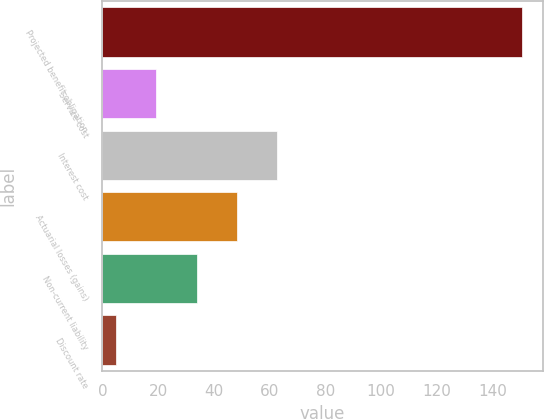Convert chart to OTSL. <chart><loc_0><loc_0><loc_500><loc_500><bar_chart><fcel>Projected benefit obligation<fcel>Service cost<fcel>Interest cost<fcel>Actuarial losses (gains)<fcel>Non-current liability<fcel>Discount rate<nl><fcel>150.53<fcel>19.23<fcel>62.82<fcel>48.29<fcel>33.76<fcel>4.7<nl></chart> 